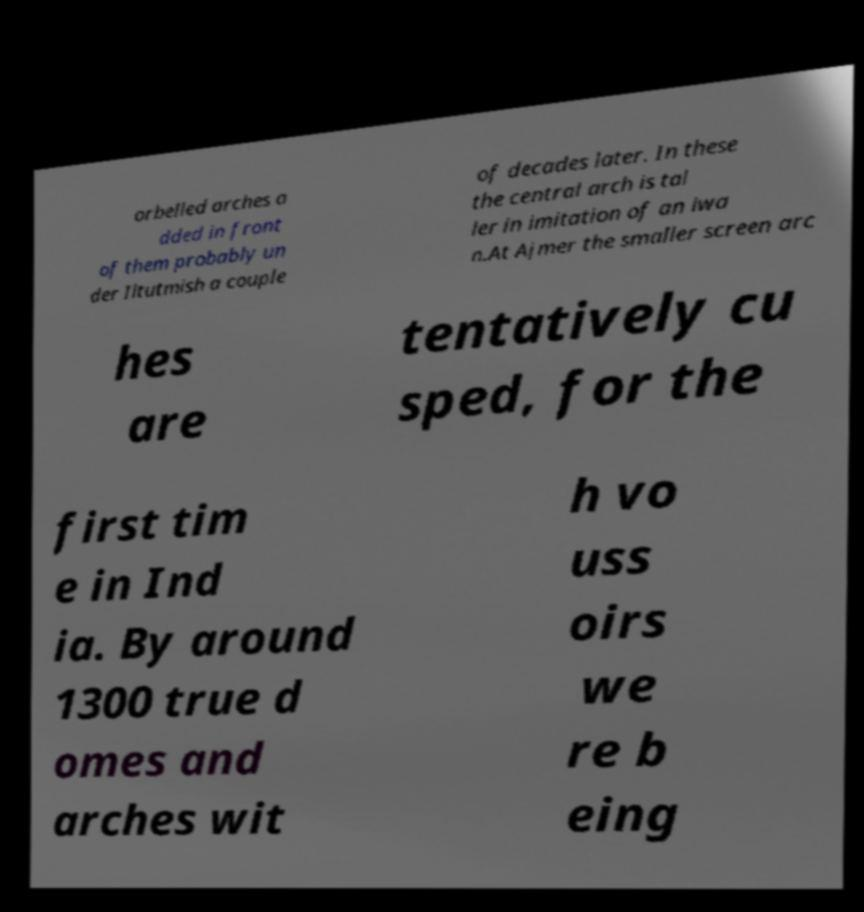What messages or text are displayed in this image? I need them in a readable, typed format. orbelled arches a dded in front of them probably un der Iltutmish a couple of decades later. In these the central arch is tal ler in imitation of an iwa n.At Ajmer the smaller screen arc hes are tentatively cu sped, for the first tim e in Ind ia. By around 1300 true d omes and arches wit h vo uss oirs we re b eing 